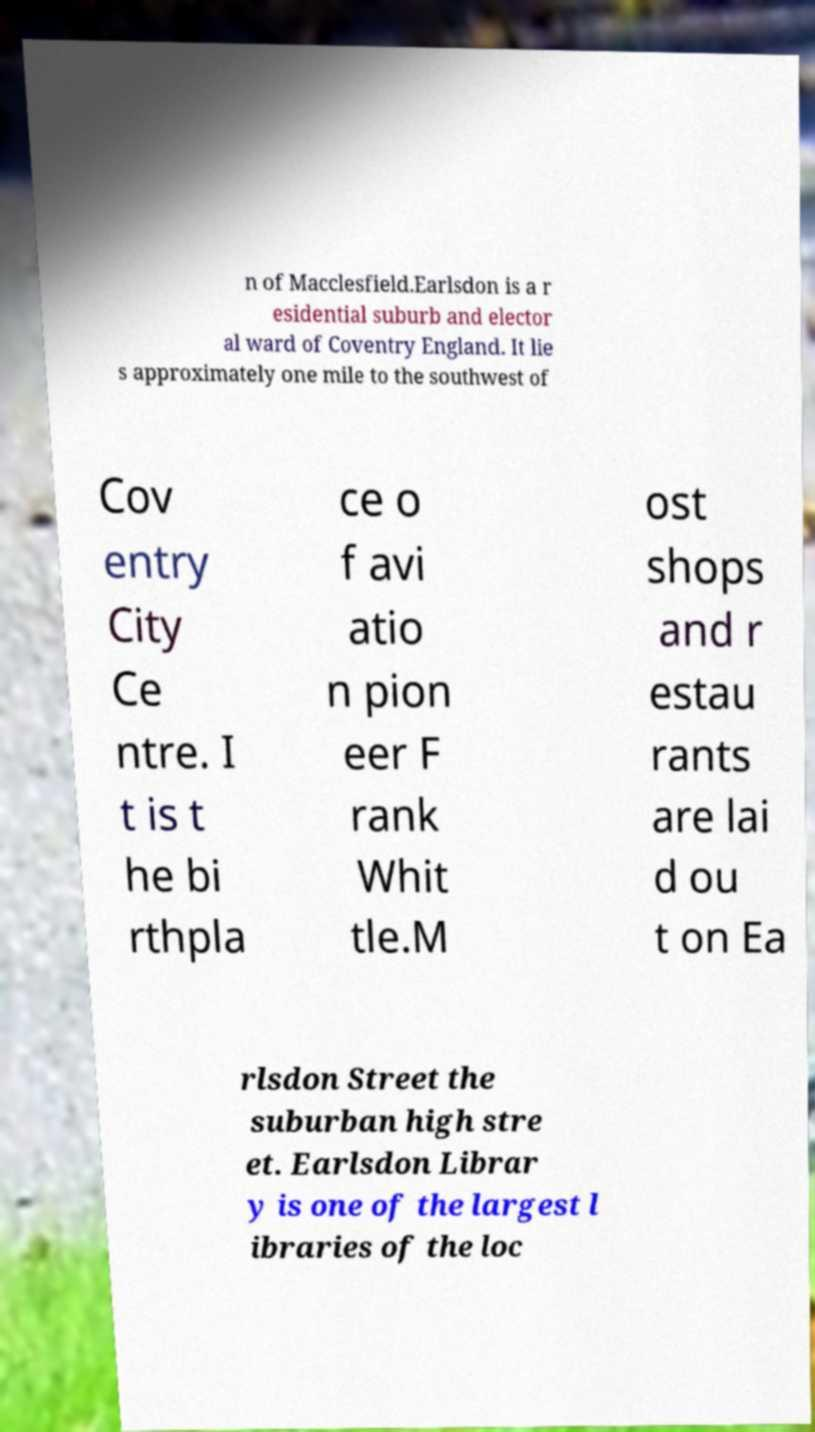Can you read and provide the text displayed in the image?This photo seems to have some interesting text. Can you extract and type it out for me? n of Macclesfield.Earlsdon is a r esidential suburb and elector al ward of Coventry England. It lie s approximately one mile to the southwest of Cov entry City Ce ntre. I t is t he bi rthpla ce o f avi atio n pion eer F rank Whit tle.M ost shops and r estau rants are lai d ou t on Ea rlsdon Street the suburban high stre et. Earlsdon Librar y is one of the largest l ibraries of the loc 